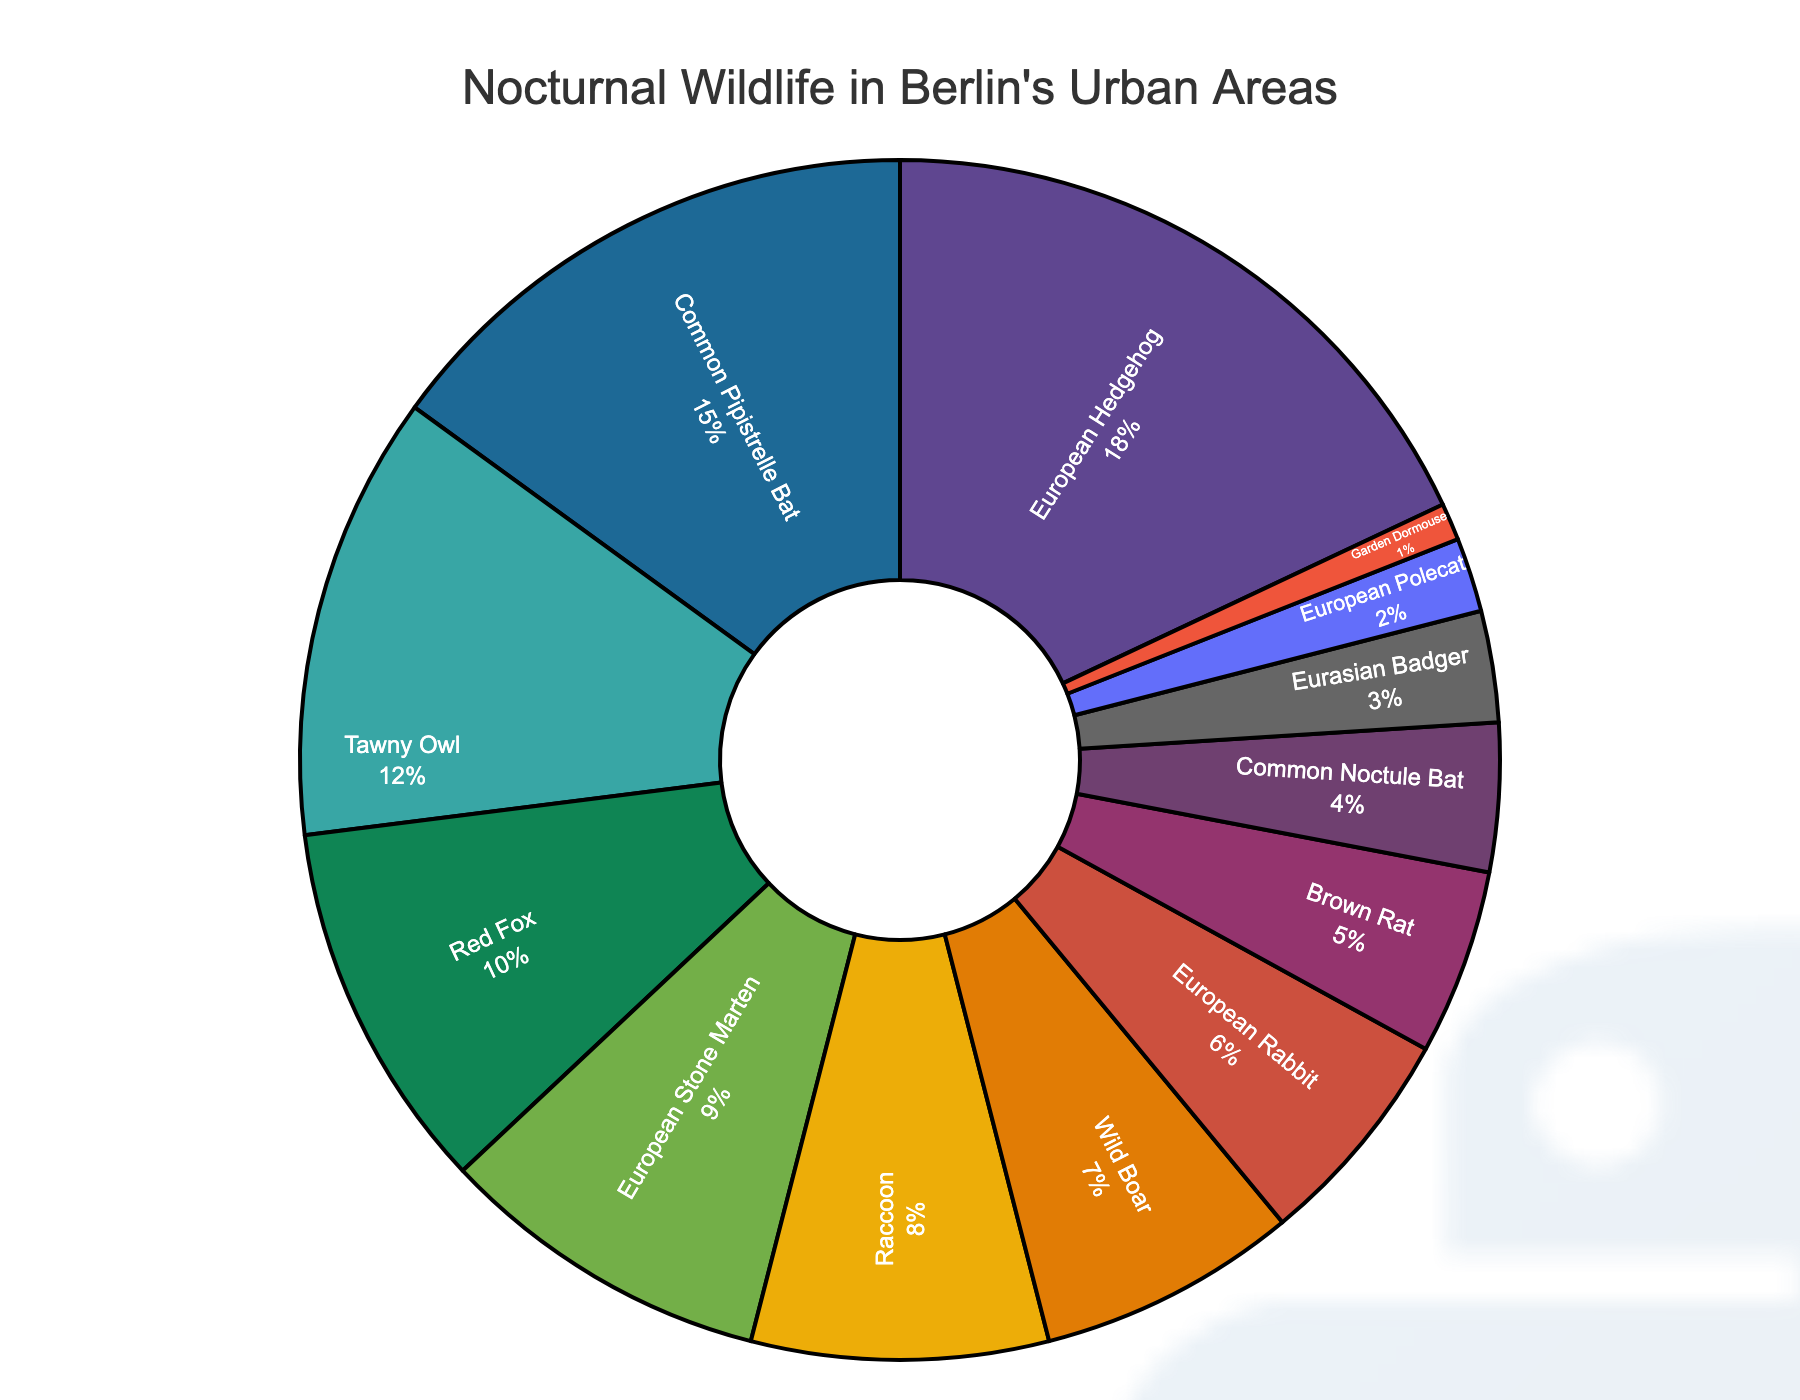What percentage of nocturnal wildlife species are European Hedgehog and Common Pipistrelle Bat together? Add the percentages of the European Hedgehog (18%) and Common Pipistrelle Bat (15%). The sum is 18 + 15 = 33.
Answer: 33% Which species represents the smallest proportion of nocturnal wildlife in Berlin's urban areas? The Garden Dormouse has the smallest proportion at 1%. This is the lowest percentage in the chart.
Answer: Garden Dormouse How does the percentage of Tawny Owl compare to that of Red Fox? The percentage of Tawny Owl is 12%, and the Red Fox is 10%. Comparing these, 12% is greater than 10%.
Answer: Tawny Owl is greater than Red Fox If you combine the percentages of the European Stone Marten, Raccoon, and Wild Boar, what is their total percentage? Add the percentages of European Stone Marten (9%), Raccoon (8%), and Wild Boar (7%). The sum is 9 + 8 + 7 = 24.
Answer: 24% What is the visual position of the segment representing the European Stone Marten? The segment for the European Stone Marten is in the middle of the pie chart, surrounded by slightly larger and smaller segments.
Answer: Middle Which species has a percentage close to the average of all the species percentages? Calculate the average by summing all percentages (100% as this is a pie chart) and dividing by the number of species (14). The average is 100 / 14 ≈ 7.1%. The Wild Boar (7%) is closest to this average.
Answer: Wild Boar Is the percentage of European Hedgehog higher or lower than the combined percentage of the Common Noctule Bat and Eurasian Badger? The percentage of the European Hedgehog is 18%. The combined percentage of the Common Noctule Bat (4%) and Eurasian Badger (3%) is 4 + 3 = 7%. 18% is higher than 7%.
Answer: Higher By how much does the percentage of the Brown Rat and Common Noctule Bat combined exceed the percentage of the European Rabbit? Add the percentages of the Brown Rat (5%) and Common Noctule Bat (4%) to get 5 + 4 = 9%. Subtract European Rabbit's percentage (6%) from this total: 9 - 6 = 3%.
Answer: 3% 